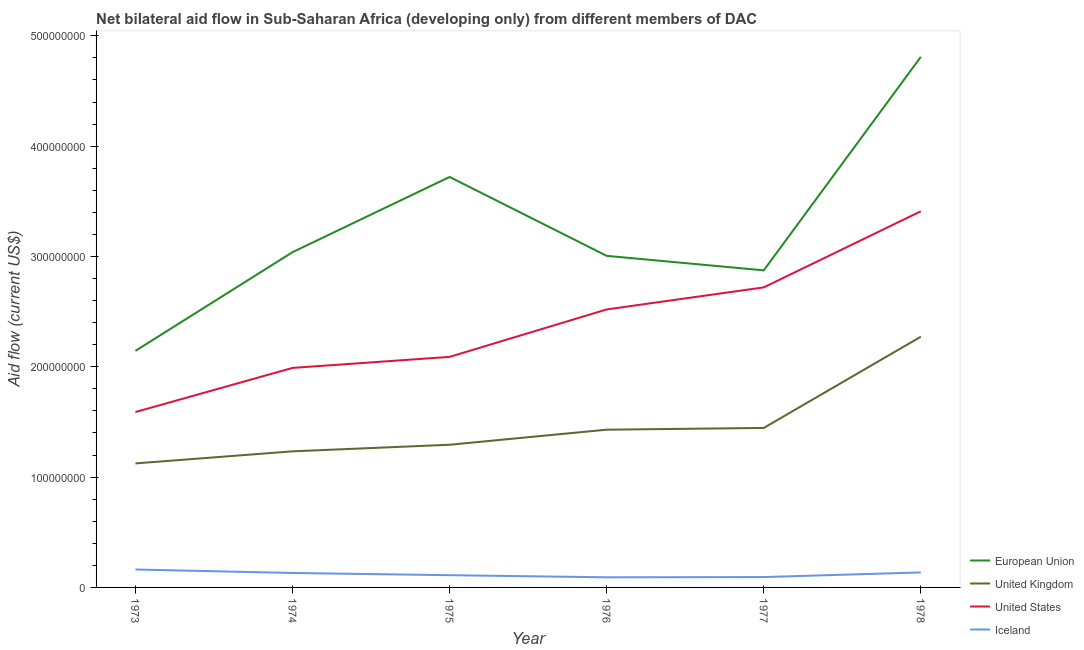Does the line corresponding to amount of aid given by iceland intersect with the line corresponding to amount of aid given by us?
Your response must be concise. No. Is the number of lines equal to the number of legend labels?
Keep it short and to the point. Yes. What is the amount of aid given by us in 1975?
Offer a terse response. 2.09e+08. Across all years, what is the maximum amount of aid given by eu?
Give a very brief answer. 4.81e+08. Across all years, what is the minimum amount of aid given by uk?
Your answer should be very brief. 1.12e+08. In which year was the amount of aid given by us maximum?
Offer a very short reply. 1978. In which year was the amount of aid given by iceland minimum?
Make the answer very short. 1976. What is the total amount of aid given by uk in the graph?
Provide a short and direct response. 8.80e+08. What is the difference between the amount of aid given by us in 1976 and that in 1978?
Provide a succinct answer. -8.90e+07. What is the difference between the amount of aid given by us in 1973 and the amount of aid given by uk in 1974?
Give a very brief answer. 3.56e+07. What is the average amount of aid given by us per year?
Give a very brief answer. 2.39e+08. In the year 1978, what is the difference between the amount of aid given by uk and amount of aid given by iceland?
Provide a succinct answer. 2.14e+08. What is the ratio of the amount of aid given by eu in 1974 to that in 1977?
Give a very brief answer. 1.06. What is the difference between the highest and the second highest amount of aid given by eu?
Offer a terse response. 1.09e+08. What is the difference between the highest and the lowest amount of aid given by iceland?
Keep it short and to the point. 7.07e+06. Is the sum of the amount of aid given by uk in 1974 and 1978 greater than the maximum amount of aid given by eu across all years?
Your answer should be very brief. No. Is it the case that in every year, the sum of the amount of aid given by eu and amount of aid given by uk is greater than the amount of aid given by us?
Your answer should be very brief. Yes. What is the difference between two consecutive major ticks on the Y-axis?
Make the answer very short. 1.00e+08. Does the graph contain any zero values?
Provide a short and direct response. No. Does the graph contain grids?
Keep it short and to the point. No. How are the legend labels stacked?
Ensure brevity in your answer.  Vertical. What is the title of the graph?
Your answer should be compact. Net bilateral aid flow in Sub-Saharan Africa (developing only) from different members of DAC. What is the Aid flow (current US$) of European Union in 1973?
Give a very brief answer. 2.14e+08. What is the Aid flow (current US$) in United Kingdom in 1973?
Your answer should be compact. 1.12e+08. What is the Aid flow (current US$) of United States in 1973?
Your answer should be compact. 1.59e+08. What is the Aid flow (current US$) in Iceland in 1973?
Your answer should be very brief. 1.62e+07. What is the Aid flow (current US$) in European Union in 1974?
Keep it short and to the point. 3.04e+08. What is the Aid flow (current US$) in United Kingdom in 1974?
Your answer should be very brief. 1.23e+08. What is the Aid flow (current US$) in United States in 1974?
Ensure brevity in your answer.  1.99e+08. What is the Aid flow (current US$) in Iceland in 1974?
Give a very brief answer. 1.31e+07. What is the Aid flow (current US$) of European Union in 1975?
Offer a very short reply. 3.72e+08. What is the Aid flow (current US$) of United Kingdom in 1975?
Provide a succinct answer. 1.29e+08. What is the Aid flow (current US$) of United States in 1975?
Make the answer very short. 2.09e+08. What is the Aid flow (current US$) of Iceland in 1975?
Provide a short and direct response. 1.11e+07. What is the Aid flow (current US$) in European Union in 1976?
Offer a very short reply. 3.01e+08. What is the Aid flow (current US$) in United Kingdom in 1976?
Make the answer very short. 1.43e+08. What is the Aid flow (current US$) in United States in 1976?
Your answer should be very brief. 2.52e+08. What is the Aid flow (current US$) in Iceland in 1976?
Keep it short and to the point. 9.18e+06. What is the Aid flow (current US$) of European Union in 1977?
Provide a succinct answer. 2.87e+08. What is the Aid flow (current US$) of United Kingdom in 1977?
Offer a very short reply. 1.45e+08. What is the Aid flow (current US$) in United States in 1977?
Ensure brevity in your answer.  2.72e+08. What is the Aid flow (current US$) of Iceland in 1977?
Offer a terse response. 9.40e+06. What is the Aid flow (current US$) in European Union in 1978?
Keep it short and to the point. 4.81e+08. What is the Aid flow (current US$) of United Kingdom in 1978?
Provide a short and direct response. 2.27e+08. What is the Aid flow (current US$) of United States in 1978?
Ensure brevity in your answer.  3.41e+08. What is the Aid flow (current US$) of Iceland in 1978?
Provide a short and direct response. 1.36e+07. Across all years, what is the maximum Aid flow (current US$) of European Union?
Your response must be concise. 4.81e+08. Across all years, what is the maximum Aid flow (current US$) in United Kingdom?
Provide a succinct answer. 2.27e+08. Across all years, what is the maximum Aid flow (current US$) of United States?
Offer a very short reply. 3.41e+08. Across all years, what is the maximum Aid flow (current US$) of Iceland?
Ensure brevity in your answer.  1.62e+07. Across all years, what is the minimum Aid flow (current US$) of European Union?
Your answer should be very brief. 2.14e+08. Across all years, what is the minimum Aid flow (current US$) in United Kingdom?
Provide a short and direct response. 1.12e+08. Across all years, what is the minimum Aid flow (current US$) in United States?
Offer a terse response. 1.59e+08. Across all years, what is the minimum Aid flow (current US$) in Iceland?
Keep it short and to the point. 9.18e+06. What is the total Aid flow (current US$) of European Union in the graph?
Your response must be concise. 1.96e+09. What is the total Aid flow (current US$) in United Kingdom in the graph?
Provide a short and direct response. 8.80e+08. What is the total Aid flow (current US$) of United States in the graph?
Your answer should be very brief. 1.43e+09. What is the total Aid flow (current US$) in Iceland in the graph?
Give a very brief answer. 7.26e+07. What is the difference between the Aid flow (current US$) of European Union in 1973 and that in 1974?
Keep it short and to the point. -8.95e+07. What is the difference between the Aid flow (current US$) in United Kingdom in 1973 and that in 1974?
Your response must be concise. -1.10e+07. What is the difference between the Aid flow (current US$) of United States in 1973 and that in 1974?
Give a very brief answer. -4.00e+07. What is the difference between the Aid flow (current US$) of Iceland in 1973 and that in 1974?
Keep it short and to the point. 3.15e+06. What is the difference between the Aid flow (current US$) in European Union in 1973 and that in 1975?
Provide a short and direct response. -1.58e+08. What is the difference between the Aid flow (current US$) of United Kingdom in 1973 and that in 1975?
Make the answer very short. -1.69e+07. What is the difference between the Aid flow (current US$) of United States in 1973 and that in 1975?
Your answer should be compact. -5.00e+07. What is the difference between the Aid flow (current US$) in Iceland in 1973 and that in 1975?
Your response must be concise. 5.15e+06. What is the difference between the Aid flow (current US$) in European Union in 1973 and that in 1976?
Offer a terse response. -8.61e+07. What is the difference between the Aid flow (current US$) in United Kingdom in 1973 and that in 1976?
Your response must be concise. -3.06e+07. What is the difference between the Aid flow (current US$) in United States in 1973 and that in 1976?
Your answer should be compact. -9.30e+07. What is the difference between the Aid flow (current US$) of Iceland in 1973 and that in 1976?
Make the answer very short. 7.07e+06. What is the difference between the Aid flow (current US$) of European Union in 1973 and that in 1977?
Provide a short and direct response. -7.30e+07. What is the difference between the Aid flow (current US$) of United Kingdom in 1973 and that in 1977?
Keep it short and to the point. -3.22e+07. What is the difference between the Aid flow (current US$) of United States in 1973 and that in 1977?
Make the answer very short. -1.13e+08. What is the difference between the Aid flow (current US$) in Iceland in 1973 and that in 1977?
Keep it short and to the point. 6.85e+06. What is the difference between the Aid flow (current US$) of European Union in 1973 and that in 1978?
Provide a succinct answer. -2.67e+08. What is the difference between the Aid flow (current US$) in United Kingdom in 1973 and that in 1978?
Make the answer very short. -1.15e+08. What is the difference between the Aid flow (current US$) of United States in 1973 and that in 1978?
Offer a very short reply. -1.82e+08. What is the difference between the Aid flow (current US$) in Iceland in 1973 and that in 1978?
Offer a terse response. 2.65e+06. What is the difference between the Aid flow (current US$) of European Union in 1974 and that in 1975?
Offer a terse response. -6.82e+07. What is the difference between the Aid flow (current US$) in United Kingdom in 1974 and that in 1975?
Your response must be concise. -5.97e+06. What is the difference between the Aid flow (current US$) in United States in 1974 and that in 1975?
Make the answer very short. -1.00e+07. What is the difference between the Aid flow (current US$) of European Union in 1974 and that in 1976?
Offer a terse response. 3.34e+06. What is the difference between the Aid flow (current US$) in United Kingdom in 1974 and that in 1976?
Keep it short and to the point. -1.96e+07. What is the difference between the Aid flow (current US$) in United States in 1974 and that in 1976?
Offer a very short reply. -5.30e+07. What is the difference between the Aid flow (current US$) of Iceland in 1974 and that in 1976?
Provide a succinct answer. 3.92e+06. What is the difference between the Aid flow (current US$) in European Union in 1974 and that in 1977?
Your answer should be very brief. 1.65e+07. What is the difference between the Aid flow (current US$) of United Kingdom in 1974 and that in 1977?
Your answer should be very brief. -2.12e+07. What is the difference between the Aid flow (current US$) of United States in 1974 and that in 1977?
Offer a very short reply. -7.30e+07. What is the difference between the Aid flow (current US$) of Iceland in 1974 and that in 1977?
Offer a terse response. 3.70e+06. What is the difference between the Aid flow (current US$) in European Union in 1974 and that in 1978?
Keep it short and to the point. -1.77e+08. What is the difference between the Aid flow (current US$) of United Kingdom in 1974 and that in 1978?
Make the answer very short. -1.04e+08. What is the difference between the Aid flow (current US$) in United States in 1974 and that in 1978?
Offer a very short reply. -1.42e+08. What is the difference between the Aid flow (current US$) of Iceland in 1974 and that in 1978?
Make the answer very short. -5.00e+05. What is the difference between the Aid flow (current US$) in European Union in 1975 and that in 1976?
Your response must be concise. 7.15e+07. What is the difference between the Aid flow (current US$) of United Kingdom in 1975 and that in 1976?
Your response must be concise. -1.37e+07. What is the difference between the Aid flow (current US$) of United States in 1975 and that in 1976?
Offer a very short reply. -4.30e+07. What is the difference between the Aid flow (current US$) of Iceland in 1975 and that in 1976?
Keep it short and to the point. 1.92e+06. What is the difference between the Aid flow (current US$) of European Union in 1975 and that in 1977?
Provide a succinct answer. 8.47e+07. What is the difference between the Aid flow (current US$) of United Kingdom in 1975 and that in 1977?
Offer a very short reply. -1.52e+07. What is the difference between the Aid flow (current US$) of United States in 1975 and that in 1977?
Keep it short and to the point. -6.30e+07. What is the difference between the Aid flow (current US$) in Iceland in 1975 and that in 1977?
Give a very brief answer. 1.70e+06. What is the difference between the Aid flow (current US$) in European Union in 1975 and that in 1978?
Offer a terse response. -1.09e+08. What is the difference between the Aid flow (current US$) of United Kingdom in 1975 and that in 1978?
Ensure brevity in your answer.  -9.80e+07. What is the difference between the Aid flow (current US$) of United States in 1975 and that in 1978?
Your answer should be compact. -1.32e+08. What is the difference between the Aid flow (current US$) in Iceland in 1975 and that in 1978?
Keep it short and to the point. -2.50e+06. What is the difference between the Aid flow (current US$) of European Union in 1976 and that in 1977?
Provide a succinct answer. 1.32e+07. What is the difference between the Aid flow (current US$) of United Kingdom in 1976 and that in 1977?
Ensure brevity in your answer.  -1.58e+06. What is the difference between the Aid flow (current US$) in United States in 1976 and that in 1977?
Keep it short and to the point. -2.00e+07. What is the difference between the Aid flow (current US$) in Iceland in 1976 and that in 1977?
Offer a very short reply. -2.20e+05. What is the difference between the Aid flow (current US$) in European Union in 1976 and that in 1978?
Your response must be concise. -1.80e+08. What is the difference between the Aid flow (current US$) of United Kingdom in 1976 and that in 1978?
Your answer should be compact. -8.43e+07. What is the difference between the Aid flow (current US$) in United States in 1976 and that in 1978?
Ensure brevity in your answer.  -8.90e+07. What is the difference between the Aid flow (current US$) of Iceland in 1976 and that in 1978?
Make the answer very short. -4.42e+06. What is the difference between the Aid flow (current US$) of European Union in 1977 and that in 1978?
Ensure brevity in your answer.  -1.94e+08. What is the difference between the Aid flow (current US$) of United Kingdom in 1977 and that in 1978?
Offer a terse response. -8.27e+07. What is the difference between the Aid flow (current US$) of United States in 1977 and that in 1978?
Keep it short and to the point. -6.90e+07. What is the difference between the Aid flow (current US$) in Iceland in 1977 and that in 1978?
Ensure brevity in your answer.  -4.20e+06. What is the difference between the Aid flow (current US$) in European Union in 1973 and the Aid flow (current US$) in United Kingdom in 1974?
Your response must be concise. 9.11e+07. What is the difference between the Aid flow (current US$) of European Union in 1973 and the Aid flow (current US$) of United States in 1974?
Your response must be concise. 1.55e+07. What is the difference between the Aid flow (current US$) in European Union in 1973 and the Aid flow (current US$) in Iceland in 1974?
Ensure brevity in your answer.  2.01e+08. What is the difference between the Aid flow (current US$) of United Kingdom in 1973 and the Aid flow (current US$) of United States in 1974?
Provide a succinct answer. -8.66e+07. What is the difference between the Aid flow (current US$) of United Kingdom in 1973 and the Aid flow (current US$) of Iceland in 1974?
Keep it short and to the point. 9.93e+07. What is the difference between the Aid flow (current US$) in United States in 1973 and the Aid flow (current US$) in Iceland in 1974?
Provide a succinct answer. 1.46e+08. What is the difference between the Aid flow (current US$) of European Union in 1973 and the Aid flow (current US$) of United Kingdom in 1975?
Your answer should be compact. 8.51e+07. What is the difference between the Aid flow (current US$) of European Union in 1973 and the Aid flow (current US$) of United States in 1975?
Your answer should be very brief. 5.46e+06. What is the difference between the Aid flow (current US$) of European Union in 1973 and the Aid flow (current US$) of Iceland in 1975?
Make the answer very short. 2.03e+08. What is the difference between the Aid flow (current US$) in United Kingdom in 1973 and the Aid flow (current US$) in United States in 1975?
Ensure brevity in your answer.  -9.66e+07. What is the difference between the Aid flow (current US$) in United Kingdom in 1973 and the Aid flow (current US$) in Iceland in 1975?
Your response must be concise. 1.01e+08. What is the difference between the Aid flow (current US$) of United States in 1973 and the Aid flow (current US$) of Iceland in 1975?
Provide a succinct answer. 1.48e+08. What is the difference between the Aid flow (current US$) in European Union in 1973 and the Aid flow (current US$) in United Kingdom in 1976?
Give a very brief answer. 7.15e+07. What is the difference between the Aid flow (current US$) of European Union in 1973 and the Aid flow (current US$) of United States in 1976?
Ensure brevity in your answer.  -3.75e+07. What is the difference between the Aid flow (current US$) of European Union in 1973 and the Aid flow (current US$) of Iceland in 1976?
Provide a short and direct response. 2.05e+08. What is the difference between the Aid flow (current US$) in United Kingdom in 1973 and the Aid flow (current US$) in United States in 1976?
Give a very brief answer. -1.40e+08. What is the difference between the Aid flow (current US$) of United Kingdom in 1973 and the Aid flow (current US$) of Iceland in 1976?
Your response must be concise. 1.03e+08. What is the difference between the Aid flow (current US$) of United States in 1973 and the Aid flow (current US$) of Iceland in 1976?
Offer a very short reply. 1.50e+08. What is the difference between the Aid flow (current US$) of European Union in 1973 and the Aid flow (current US$) of United Kingdom in 1977?
Ensure brevity in your answer.  6.99e+07. What is the difference between the Aid flow (current US$) of European Union in 1973 and the Aid flow (current US$) of United States in 1977?
Your answer should be compact. -5.75e+07. What is the difference between the Aid flow (current US$) in European Union in 1973 and the Aid flow (current US$) in Iceland in 1977?
Your answer should be very brief. 2.05e+08. What is the difference between the Aid flow (current US$) of United Kingdom in 1973 and the Aid flow (current US$) of United States in 1977?
Ensure brevity in your answer.  -1.60e+08. What is the difference between the Aid flow (current US$) of United Kingdom in 1973 and the Aid flow (current US$) of Iceland in 1977?
Your answer should be very brief. 1.03e+08. What is the difference between the Aid flow (current US$) in United States in 1973 and the Aid flow (current US$) in Iceland in 1977?
Keep it short and to the point. 1.50e+08. What is the difference between the Aid flow (current US$) of European Union in 1973 and the Aid flow (current US$) of United Kingdom in 1978?
Your answer should be compact. -1.28e+07. What is the difference between the Aid flow (current US$) of European Union in 1973 and the Aid flow (current US$) of United States in 1978?
Your answer should be very brief. -1.27e+08. What is the difference between the Aid flow (current US$) of European Union in 1973 and the Aid flow (current US$) of Iceland in 1978?
Your answer should be very brief. 2.01e+08. What is the difference between the Aid flow (current US$) of United Kingdom in 1973 and the Aid flow (current US$) of United States in 1978?
Keep it short and to the point. -2.29e+08. What is the difference between the Aid flow (current US$) of United Kingdom in 1973 and the Aid flow (current US$) of Iceland in 1978?
Provide a succinct answer. 9.88e+07. What is the difference between the Aid flow (current US$) of United States in 1973 and the Aid flow (current US$) of Iceland in 1978?
Keep it short and to the point. 1.45e+08. What is the difference between the Aid flow (current US$) of European Union in 1974 and the Aid flow (current US$) of United Kingdom in 1975?
Your answer should be very brief. 1.75e+08. What is the difference between the Aid flow (current US$) in European Union in 1974 and the Aid flow (current US$) in United States in 1975?
Offer a very short reply. 9.49e+07. What is the difference between the Aid flow (current US$) of European Union in 1974 and the Aid flow (current US$) of Iceland in 1975?
Your answer should be very brief. 2.93e+08. What is the difference between the Aid flow (current US$) in United Kingdom in 1974 and the Aid flow (current US$) in United States in 1975?
Provide a succinct answer. -8.56e+07. What is the difference between the Aid flow (current US$) in United Kingdom in 1974 and the Aid flow (current US$) in Iceland in 1975?
Offer a terse response. 1.12e+08. What is the difference between the Aid flow (current US$) in United States in 1974 and the Aid flow (current US$) in Iceland in 1975?
Your response must be concise. 1.88e+08. What is the difference between the Aid flow (current US$) in European Union in 1974 and the Aid flow (current US$) in United Kingdom in 1976?
Keep it short and to the point. 1.61e+08. What is the difference between the Aid flow (current US$) of European Union in 1974 and the Aid flow (current US$) of United States in 1976?
Offer a terse response. 5.19e+07. What is the difference between the Aid flow (current US$) of European Union in 1974 and the Aid flow (current US$) of Iceland in 1976?
Your answer should be very brief. 2.95e+08. What is the difference between the Aid flow (current US$) in United Kingdom in 1974 and the Aid flow (current US$) in United States in 1976?
Keep it short and to the point. -1.29e+08. What is the difference between the Aid flow (current US$) of United Kingdom in 1974 and the Aid flow (current US$) of Iceland in 1976?
Offer a terse response. 1.14e+08. What is the difference between the Aid flow (current US$) of United States in 1974 and the Aid flow (current US$) of Iceland in 1976?
Make the answer very short. 1.90e+08. What is the difference between the Aid flow (current US$) of European Union in 1974 and the Aid flow (current US$) of United Kingdom in 1977?
Provide a short and direct response. 1.59e+08. What is the difference between the Aid flow (current US$) of European Union in 1974 and the Aid flow (current US$) of United States in 1977?
Provide a succinct answer. 3.19e+07. What is the difference between the Aid flow (current US$) in European Union in 1974 and the Aid flow (current US$) in Iceland in 1977?
Make the answer very short. 2.95e+08. What is the difference between the Aid flow (current US$) in United Kingdom in 1974 and the Aid flow (current US$) in United States in 1977?
Your response must be concise. -1.49e+08. What is the difference between the Aid flow (current US$) of United Kingdom in 1974 and the Aid flow (current US$) of Iceland in 1977?
Keep it short and to the point. 1.14e+08. What is the difference between the Aid flow (current US$) in United States in 1974 and the Aid flow (current US$) in Iceland in 1977?
Keep it short and to the point. 1.90e+08. What is the difference between the Aid flow (current US$) in European Union in 1974 and the Aid flow (current US$) in United Kingdom in 1978?
Offer a terse response. 7.66e+07. What is the difference between the Aid flow (current US$) in European Union in 1974 and the Aid flow (current US$) in United States in 1978?
Offer a very short reply. -3.71e+07. What is the difference between the Aid flow (current US$) of European Union in 1974 and the Aid flow (current US$) of Iceland in 1978?
Ensure brevity in your answer.  2.90e+08. What is the difference between the Aid flow (current US$) of United Kingdom in 1974 and the Aid flow (current US$) of United States in 1978?
Give a very brief answer. -2.18e+08. What is the difference between the Aid flow (current US$) in United Kingdom in 1974 and the Aid flow (current US$) in Iceland in 1978?
Provide a succinct answer. 1.10e+08. What is the difference between the Aid flow (current US$) of United States in 1974 and the Aid flow (current US$) of Iceland in 1978?
Keep it short and to the point. 1.85e+08. What is the difference between the Aid flow (current US$) in European Union in 1975 and the Aid flow (current US$) in United Kingdom in 1976?
Offer a very short reply. 2.29e+08. What is the difference between the Aid flow (current US$) of European Union in 1975 and the Aid flow (current US$) of United States in 1976?
Give a very brief answer. 1.20e+08. What is the difference between the Aid flow (current US$) in European Union in 1975 and the Aid flow (current US$) in Iceland in 1976?
Your answer should be very brief. 3.63e+08. What is the difference between the Aid flow (current US$) in United Kingdom in 1975 and the Aid flow (current US$) in United States in 1976?
Keep it short and to the point. -1.23e+08. What is the difference between the Aid flow (current US$) in United Kingdom in 1975 and the Aid flow (current US$) in Iceland in 1976?
Your answer should be compact. 1.20e+08. What is the difference between the Aid flow (current US$) of United States in 1975 and the Aid flow (current US$) of Iceland in 1976?
Ensure brevity in your answer.  2.00e+08. What is the difference between the Aid flow (current US$) in European Union in 1975 and the Aid flow (current US$) in United Kingdom in 1977?
Offer a very short reply. 2.28e+08. What is the difference between the Aid flow (current US$) in European Union in 1975 and the Aid flow (current US$) in United States in 1977?
Give a very brief answer. 1.00e+08. What is the difference between the Aid flow (current US$) of European Union in 1975 and the Aid flow (current US$) of Iceland in 1977?
Keep it short and to the point. 3.63e+08. What is the difference between the Aid flow (current US$) in United Kingdom in 1975 and the Aid flow (current US$) in United States in 1977?
Offer a very short reply. -1.43e+08. What is the difference between the Aid flow (current US$) in United Kingdom in 1975 and the Aid flow (current US$) in Iceland in 1977?
Offer a very short reply. 1.20e+08. What is the difference between the Aid flow (current US$) in United States in 1975 and the Aid flow (current US$) in Iceland in 1977?
Keep it short and to the point. 2.00e+08. What is the difference between the Aid flow (current US$) in European Union in 1975 and the Aid flow (current US$) in United Kingdom in 1978?
Keep it short and to the point. 1.45e+08. What is the difference between the Aid flow (current US$) in European Union in 1975 and the Aid flow (current US$) in United States in 1978?
Offer a terse response. 3.11e+07. What is the difference between the Aid flow (current US$) in European Union in 1975 and the Aid flow (current US$) in Iceland in 1978?
Make the answer very short. 3.58e+08. What is the difference between the Aid flow (current US$) of United Kingdom in 1975 and the Aid flow (current US$) of United States in 1978?
Offer a terse response. -2.12e+08. What is the difference between the Aid flow (current US$) in United Kingdom in 1975 and the Aid flow (current US$) in Iceland in 1978?
Ensure brevity in your answer.  1.16e+08. What is the difference between the Aid flow (current US$) in United States in 1975 and the Aid flow (current US$) in Iceland in 1978?
Your response must be concise. 1.95e+08. What is the difference between the Aid flow (current US$) in European Union in 1976 and the Aid flow (current US$) in United Kingdom in 1977?
Ensure brevity in your answer.  1.56e+08. What is the difference between the Aid flow (current US$) in European Union in 1976 and the Aid flow (current US$) in United States in 1977?
Offer a terse response. 2.86e+07. What is the difference between the Aid flow (current US$) in European Union in 1976 and the Aid flow (current US$) in Iceland in 1977?
Your answer should be compact. 2.91e+08. What is the difference between the Aid flow (current US$) in United Kingdom in 1976 and the Aid flow (current US$) in United States in 1977?
Offer a very short reply. -1.29e+08. What is the difference between the Aid flow (current US$) in United Kingdom in 1976 and the Aid flow (current US$) in Iceland in 1977?
Provide a short and direct response. 1.34e+08. What is the difference between the Aid flow (current US$) in United States in 1976 and the Aid flow (current US$) in Iceland in 1977?
Keep it short and to the point. 2.43e+08. What is the difference between the Aid flow (current US$) in European Union in 1976 and the Aid flow (current US$) in United Kingdom in 1978?
Offer a terse response. 7.33e+07. What is the difference between the Aid flow (current US$) of European Union in 1976 and the Aid flow (current US$) of United States in 1978?
Make the answer very short. -4.04e+07. What is the difference between the Aid flow (current US$) of European Union in 1976 and the Aid flow (current US$) of Iceland in 1978?
Your response must be concise. 2.87e+08. What is the difference between the Aid flow (current US$) of United Kingdom in 1976 and the Aid flow (current US$) of United States in 1978?
Ensure brevity in your answer.  -1.98e+08. What is the difference between the Aid flow (current US$) in United Kingdom in 1976 and the Aid flow (current US$) in Iceland in 1978?
Your answer should be very brief. 1.29e+08. What is the difference between the Aid flow (current US$) of United States in 1976 and the Aid flow (current US$) of Iceland in 1978?
Offer a very short reply. 2.38e+08. What is the difference between the Aid flow (current US$) in European Union in 1977 and the Aid flow (current US$) in United Kingdom in 1978?
Your response must be concise. 6.01e+07. What is the difference between the Aid flow (current US$) in European Union in 1977 and the Aid flow (current US$) in United States in 1978?
Make the answer very short. -5.36e+07. What is the difference between the Aid flow (current US$) of European Union in 1977 and the Aid flow (current US$) of Iceland in 1978?
Provide a short and direct response. 2.74e+08. What is the difference between the Aid flow (current US$) in United Kingdom in 1977 and the Aid flow (current US$) in United States in 1978?
Offer a very short reply. -1.96e+08. What is the difference between the Aid flow (current US$) of United Kingdom in 1977 and the Aid flow (current US$) of Iceland in 1978?
Provide a short and direct response. 1.31e+08. What is the difference between the Aid flow (current US$) of United States in 1977 and the Aid flow (current US$) of Iceland in 1978?
Provide a succinct answer. 2.58e+08. What is the average Aid flow (current US$) of European Union per year?
Give a very brief answer. 3.27e+08. What is the average Aid flow (current US$) in United Kingdom per year?
Your answer should be compact. 1.47e+08. What is the average Aid flow (current US$) in United States per year?
Keep it short and to the point. 2.39e+08. What is the average Aid flow (current US$) in Iceland per year?
Offer a terse response. 1.21e+07. In the year 1973, what is the difference between the Aid flow (current US$) of European Union and Aid flow (current US$) of United Kingdom?
Provide a succinct answer. 1.02e+08. In the year 1973, what is the difference between the Aid flow (current US$) in European Union and Aid flow (current US$) in United States?
Provide a succinct answer. 5.55e+07. In the year 1973, what is the difference between the Aid flow (current US$) in European Union and Aid flow (current US$) in Iceland?
Keep it short and to the point. 1.98e+08. In the year 1973, what is the difference between the Aid flow (current US$) in United Kingdom and Aid flow (current US$) in United States?
Provide a short and direct response. -4.66e+07. In the year 1973, what is the difference between the Aid flow (current US$) in United Kingdom and Aid flow (current US$) in Iceland?
Your answer should be compact. 9.62e+07. In the year 1973, what is the difference between the Aid flow (current US$) of United States and Aid flow (current US$) of Iceland?
Keep it short and to the point. 1.43e+08. In the year 1974, what is the difference between the Aid flow (current US$) of European Union and Aid flow (current US$) of United Kingdom?
Offer a terse response. 1.81e+08. In the year 1974, what is the difference between the Aid flow (current US$) of European Union and Aid flow (current US$) of United States?
Offer a very short reply. 1.05e+08. In the year 1974, what is the difference between the Aid flow (current US$) of European Union and Aid flow (current US$) of Iceland?
Keep it short and to the point. 2.91e+08. In the year 1974, what is the difference between the Aid flow (current US$) in United Kingdom and Aid flow (current US$) in United States?
Offer a terse response. -7.56e+07. In the year 1974, what is the difference between the Aid flow (current US$) of United Kingdom and Aid flow (current US$) of Iceland?
Offer a terse response. 1.10e+08. In the year 1974, what is the difference between the Aid flow (current US$) in United States and Aid flow (current US$) in Iceland?
Provide a short and direct response. 1.86e+08. In the year 1975, what is the difference between the Aid flow (current US$) of European Union and Aid flow (current US$) of United Kingdom?
Make the answer very short. 2.43e+08. In the year 1975, what is the difference between the Aid flow (current US$) in European Union and Aid flow (current US$) in United States?
Your answer should be very brief. 1.63e+08. In the year 1975, what is the difference between the Aid flow (current US$) in European Union and Aid flow (current US$) in Iceland?
Keep it short and to the point. 3.61e+08. In the year 1975, what is the difference between the Aid flow (current US$) in United Kingdom and Aid flow (current US$) in United States?
Make the answer very short. -7.97e+07. In the year 1975, what is the difference between the Aid flow (current US$) of United Kingdom and Aid flow (current US$) of Iceland?
Make the answer very short. 1.18e+08. In the year 1975, what is the difference between the Aid flow (current US$) of United States and Aid flow (current US$) of Iceland?
Provide a succinct answer. 1.98e+08. In the year 1976, what is the difference between the Aid flow (current US$) of European Union and Aid flow (current US$) of United Kingdom?
Ensure brevity in your answer.  1.58e+08. In the year 1976, what is the difference between the Aid flow (current US$) of European Union and Aid flow (current US$) of United States?
Keep it short and to the point. 4.86e+07. In the year 1976, what is the difference between the Aid flow (current US$) in European Union and Aid flow (current US$) in Iceland?
Provide a succinct answer. 2.91e+08. In the year 1976, what is the difference between the Aid flow (current US$) of United Kingdom and Aid flow (current US$) of United States?
Make the answer very short. -1.09e+08. In the year 1976, what is the difference between the Aid flow (current US$) of United Kingdom and Aid flow (current US$) of Iceland?
Make the answer very short. 1.34e+08. In the year 1976, what is the difference between the Aid flow (current US$) in United States and Aid flow (current US$) in Iceland?
Your answer should be very brief. 2.43e+08. In the year 1977, what is the difference between the Aid flow (current US$) of European Union and Aid flow (current US$) of United Kingdom?
Your answer should be compact. 1.43e+08. In the year 1977, what is the difference between the Aid flow (current US$) of European Union and Aid flow (current US$) of United States?
Your answer should be very brief. 1.54e+07. In the year 1977, what is the difference between the Aid flow (current US$) in European Union and Aid flow (current US$) in Iceland?
Offer a terse response. 2.78e+08. In the year 1977, what is the difference between the Aid flow (current US$) in United Kingdom and Aid flow (current US$) in United States?
Ensure brevity in your answer.  -1.27e+08. In the year 1977, what is the difference between the Aid flow (current US$) in United Kingdom and Aid flow (current US$) in Iceland?
Provide a succinct answer. 1.35e+08. In the year 1977, what is the difference between the Aid flow (current US$) of United States and Aid flow (current US$) of Iceland?
Your answer should be compact. 2.63e+08. In the year 1978, what is the difference between the Aid flow (current US$) of European Union and Aid flow (current US$) of United Kingdom?
Give a very brief answer. 2.54e+08. In the year 1978, what is the difference between the Aid flow (current US$) in European Union and Aid flow (current US$) in United States?
Offer a terse response. 1.40e+08. In the year 1978, what is the difference between the Aid flow (current US$) of European Union and Aid flow (current US$) of Iceland?
Make the answer very short. 4.67e+08. In the year 1978, what is the difference between the Aid flow (current US$) in United Kingdom and Aid flow (current US$) in United States?
Provide a short and direct response. -1.14e+08. In the year 1978, what is the difference between the Aid flow (current US$) in United Kingdom and Aid flow (current US$) in Iceland?
Keep it short and to the point. 2.14e+08. In the year 1978, what is the difference between the Aid flow (current US$) in United States and Aid flow (current US$) in Iceland?
Keep it short and to the point. 3.27e+08. What is the ratio of the Aid flow (current US$) in European Union in 1973 to that in 1974?
Give a very brief answer. 0.71. What is the ratio of the Aid flow (current US$) in United Kingdom in 1973 to that in 1974?
Your answer should be very brief. 0.91. What is the ratio of the Aid flow (current US$) of United States in 1973 to that in 1974?
Your response must be concise. 0.8. What is the ratio of the Aid flow (current US$) in Iceland in 1973 to that in 1974?
Offer a very short reply. 1.24. What is the ratio of the Aid flow (current US$) in European Union in 1973 to that in 1975?
Your answer should be very brief. 0.58. What is the ratio of the Aid flow (current US$) in United Kingdom in 1973 to that in 1975?
Your answer should be compact. 0.87. What is the ratio of the Aid flow (current US$) in United States in 1973 to that in 1975?
Your answer should be compact. 0.76. What is the ratio of the Aid flow (current US$) in Iceland in 1973 to that in 1975?
Provide a short and direct response. 1.46. What is the ratio of the Aid flow (current US$) of European Union in 1973 to that in 1976?
Provide a short and direct response. 0.71. What is the ratio of the Aid flow (current US$) in United Kingdom in 1973 to that in 1976?
Offer a terse response. 0.79. What is the ratio of the Aid flow (current US$) in United States in 1973 to that in 1976?
Ensure brevity in your answer.  0.63. What is the ratio of the Aid flow (current US$) in Iceland in 1973 to that in 1976?
Provide a succinct answer. 1.77. What is the ratio of the Aid flow (current US$) of European Union in 1973 to that in 1977?
Your answer should be very brief. 0.75. What is the ratio of the Aid flow (current US$) in United Kingdom in 1973 to that in 1977?
Give a very brief answer. 0.78. What is the ratio of the Aid flow (current US$) in United States in 1973 to that in 1977?
Give a very brief answer. 0.58. What is the ratio of the Aid flow (current US$) of Iceland in 1973 to that in 1977?
Make the answer very short. 1.73. What is the ratio of the Aid flow (current US$) in European Union in 1973 to that in 1978?
Your answer should be compact. 0.45. What is the ratio of the Aid flow (current US$) in United Kingdom in 1973 to that in 1978?
Your answer should be compact. 0.49. What is the ratio of the Aid flow (current US$) in United States in 1973 to that in 1978?
Your answer should be compact. 0.47. What is the ratio of the Aid flow (current US$) in Iceland in 1973 to that in 1978?
Ensure brevity in your answer.  1.19. What is the ratio of the Aid flow (current US$) of European Union in 1974 to that in 1975?
Provide a short and direct response. 0.82. What is the ratio of the Aid flow (current US$) of United Kingdom in 1974 to that in 1975?
Your answer should be very brief. 0.95. What is the ratio of the Aid flow (current US$) in United States in 1974 to that in 1975?
Your answer should be very brief. 0.95. What is the ratio of the Aid flow (current US$) of Iceland in 1974 to that in 1975?
Ensure brevity in your answer.  1.18. What is the ratio of the Aid flow (current US$) in European Union in 1974 to that in 1976?
Provide a short and direct response. 1.01. What is the ratio of the Aid flow (current US$) in United Kingdom in 1974 to that in 1976?
Provide a succinct answer. 0.86. What is the ratio of the Aid flow (current US$) of United States in 1974 to that in 1976?
Offer a very short reply. 0.79. What is the ratio of the Aid flow (current US$) of Iceland in 1974 to that in 1976?
Give a very brief answer. 1.43. What is the ratio of the Aid flow (current US$) in European Union in 1974 to that in 1977?
Your answer should be very brief. 1.06. What is the ratio of the Aid flow (current US$) of United Kingdom in 1974 to that in 1977?
Provide a succinct answer. 0.85. What is the ratio of the Aid flow (current US$) in United States in 1974 to that in 1977?
Your response must be concise. 0.73. What is the ratio of the Aid flow (current US$) in Iceland in 1974 to that in 1977?
Provide a succinct answer. 1.39. What is the ratio of the Aid flow (current US$) of European Union in 1974 to that in 1978?
Ensure brevity in your answer.  0.63. What is the ratio of the Aid flow (current US$) of United Kingdom in 1974 to that in 1978?
Provide a succinct answer. 0.54. What is the ratio of the Aid flow (current US$) of United States in 1974 to that in 1978?
Keep it short and to the point. 0.58. What is the ratio of the Aid flow (current US$) in Iceland in 1974 to that in 1978?
Offer a terse response. 0.96. What is the ratio of the Aid flow (current US$) in European Union in 1975 to that in 1976?
Keep it short and to the point. 1.24. What is the ratio of the Aid flow (current US$) in United Kingdom in 1975 to that in 1976?
Your answer should be compact. 0.9. What is the ratio of the Aid flow (current US$) in United States in 1975 to that in 1976?
Provide a succinct answer. 0.83. What is the ratio of the Aid flow (current US$) in Iceland in 1975 to that in 1976?
Provide a short and direct response. 1.21. What is the ratio of the Aid flow (current US$) of European Union in 1975 to that in 1977?
Provide a succinct answer. 1.29. What is the ratio of the Aid flow (current US$) of United Kingdom in 1975 to that in 1977?
Offer a terse response. 0.89. What is the ratio of the Aid flow (current US$) in United States in 1975 to that in 1977?
Make the answer very short. 0.77. What is the ratio of the Aid flow (current US$) of Iceland in 1975 to that in 1977?
Ensure brevity in your answer.  1.18. What is the ratio of the Aid flow (current US$) of European Union in 1975 to that in 1978?
Give a very brief answer. 0.77. What is the ratio of the Aid flow (current US$) in United Kingdom in 1975 to that in 1978?
Ensure brevity in your answer.  0.57. What is the ratio of the Aid flow (current US$) of United States in 1975 to that in 1978?
Offer a terse response. 0.61. What is the ratio of the Aid flow (current US$) in Iceland in 1975 to that in 1978?
Provide a succinct answer. 0.82. What is the ratio of the Aid flow (current US$) of European Union in 1976 to that in 1977?
Give a very brief answer. 1.05. What is the ratio of the Aid flow (current US$) of United States in 1976 to that in 1977?
Ensure brevity in your answer.  0.93. What is the ratio of the Aid flow (current US$) of Iceland in 1976 to that in 1977?
Offer a terse response. 0.98. What is the ratio of the Aid flow (current US$) of European Union in 1976 to that in 1978?
Ensure brevity in your answer.  0.62. What is the ratio of the Aid flow (current US$) of United Kingdom in 1976 to that in 1978?
Your response must be concise. 0.63. What is the ratio of the Aid flow (current US$) of United States in 1976 to that in 1978?
Your response must be concise. 0.74. What is the ratio of the Aid flow (current US$) in Iceland in 1976 to that in 1978?
Your answer should be compact. 0.68. What is the ratio of the Aid flow (current US$) in European Union in 1977 to that in 1978?
Offer a very short reply. 0.6. What is the ratio of the Aid flow (current US$) in United Kingdom in 1977 to that in 1978?
Your answer should be compact. 0.64. What is the ratio of the Aid flow (current US$) in United States in 1977 to that in 1978?
Offer a terse response. 0.8. What is the ratio of the Aid flow (current US$) in Iceland in 1977 to that in 1978?
Your response must be concise. 0.69. What is the difference between the highest and the second highest Aid flow (current US$) in European Union?
Ensure brevity in your answer.  1.09e+08. What is the difference between the highest and the second highest Aid flow (current US$) in United Kingdom?
Your response must be concise. 8.27e+07. What is the difference between the highest and the second highest Aid flow (current US$) of United States?
Provide a short and direct response. 6.90e+07. What is the difference between the highest and the second highest Aid flow (current US$) in Iceland?
Your answer should be very brief. 2.65e+06. What is the difference between the highest and the lowest Aid flow (current US$) in European Union?
Provide a short and direct response. 2.67e+08. What is the difference between the highest and the lowest Aid flow (current US$) in United Kingdom?
Offer a very short reply. 1.15e+08. What is the difference between the highest and the lowest Aid flow (current US$) of United States?
Offer a very short reply. 1.82e+08. What is the difference between the highest and the lowest Aid flow (current US$) in Iceland?
Make the answer very short. 7.07e+06. 